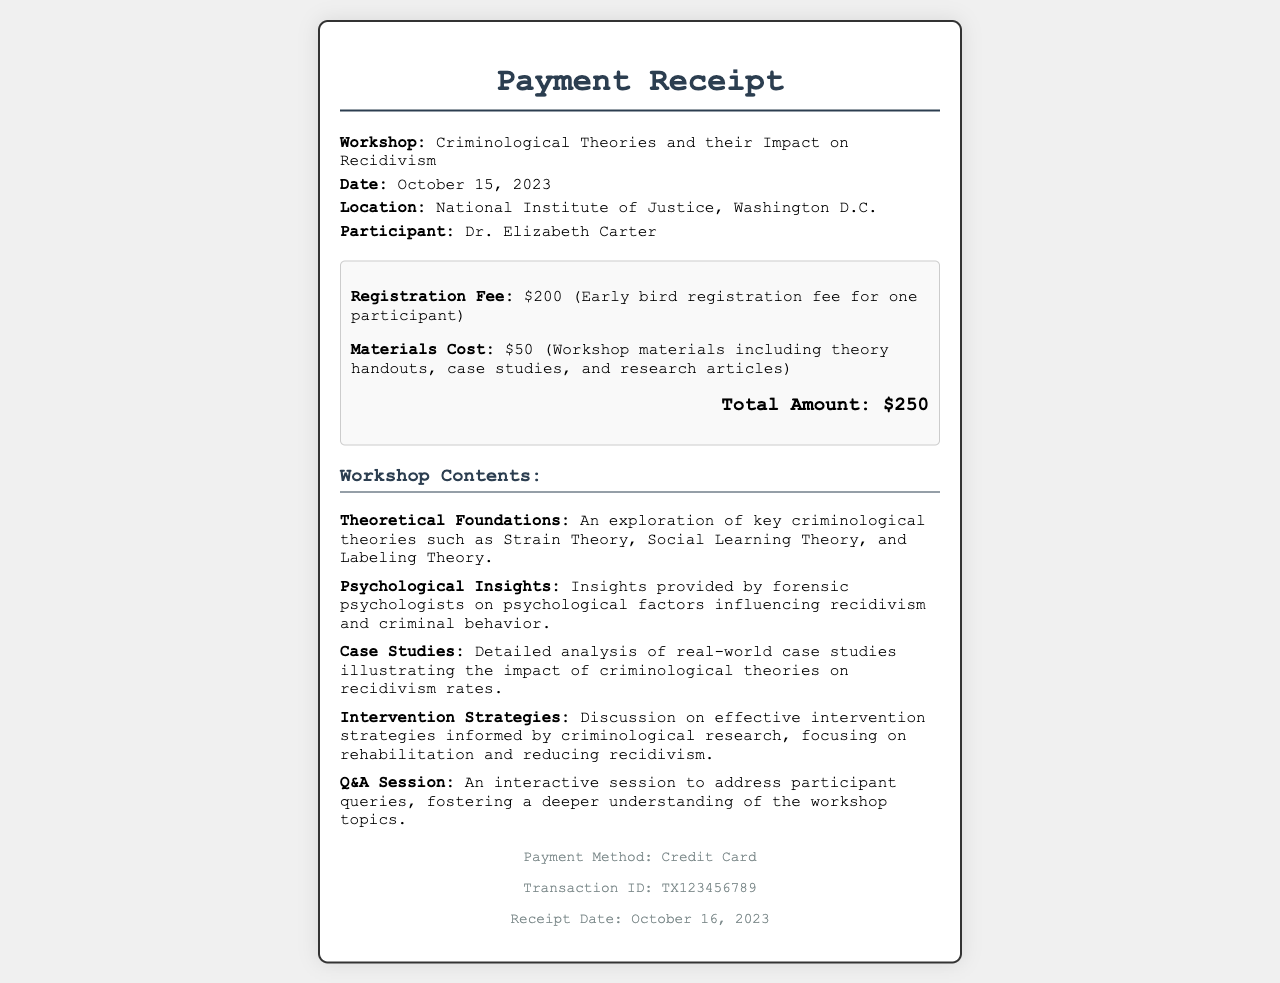What is the participant's name? The participant's name is listed in the receipt section under "Participant."
Answer: Dr. Elizabeth Carter What is the registration fee? The registration fee is clearly stated in the cost breakdown as a specific amount.
Answer: $200 When was the workshop held? The date of the workshop is provided in the information section of the receipt.
Answer: October 15, 2023 What is the total amount paid? The total amount is summarized at the bottom of the cost breakdown section.
Answer: $250 What location hosted the workshop? The location is specified in the information section of the receipt.
Answer: National Institute of Justice, Washington D.C What type of payment method was used? The payment method is mentioned at the end of the document.
Answer: Credit Card How many contents are listed in the workshop summary? The number of items in the workshop contents can be counted from the list provided in the document.
Answer: Five What is one of the psychological insights discussed in the workshop? The insights provided by forensic psychologists focus on specific factors influencing behavior.
Answer: Psychological factors influencing recidivism What is the transaction ID for this payment? The transaction ID is noted in the footer section of the receipt.
Answer: TX123456789 